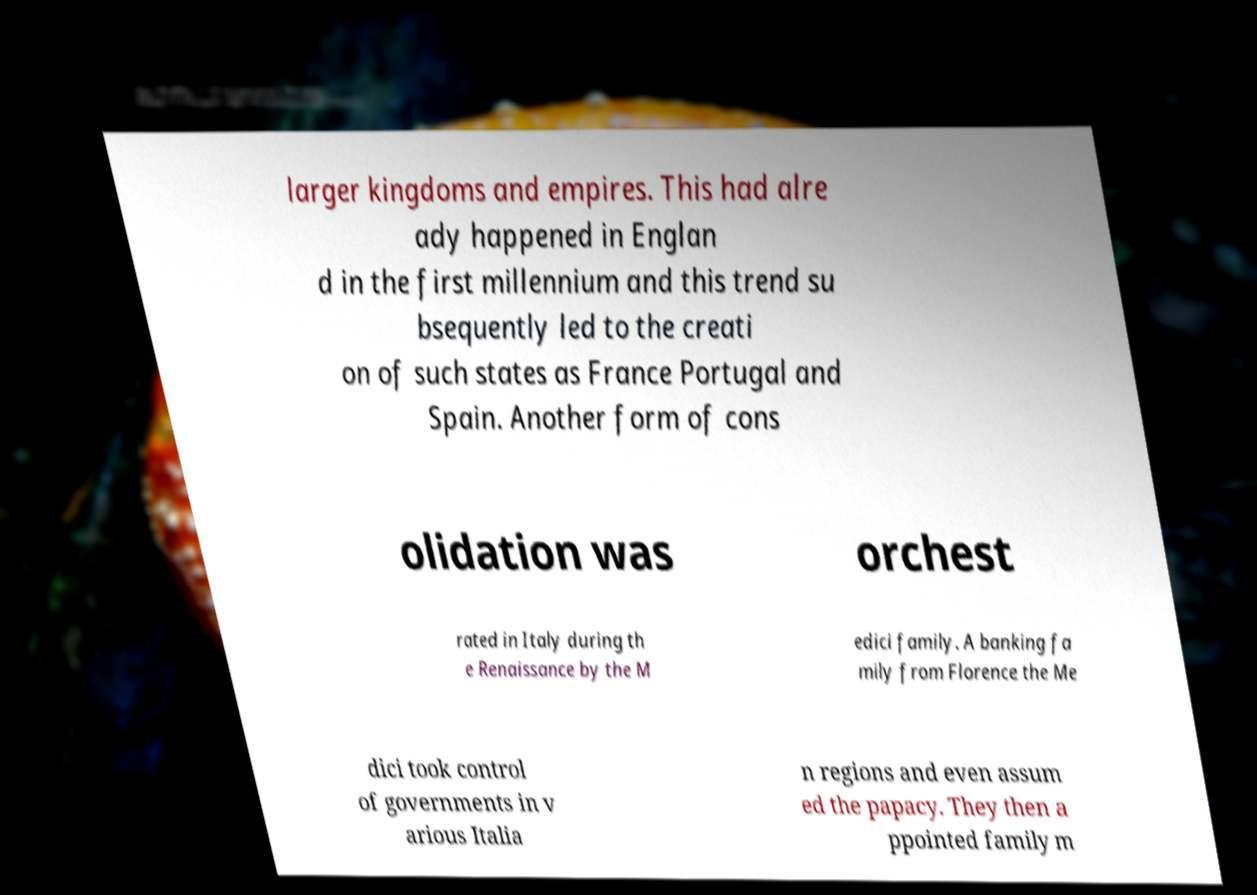There's text embedded in this image that I need extracted. Can you transcribe it verbatim? larger kingdoms and empires. This had alre ady happened in Englan d in the first millennium and this trend su bsequently led to the creati on of such states as France Portugal and Spain. Another form of cons olidation was orchest rated in Italy during th e Renaissance by the M edici family. A banking fa mily from Florence the Me dici took control of governments in v arious Italia n regions and even assum ed the papacy. They then a ppointed family m 